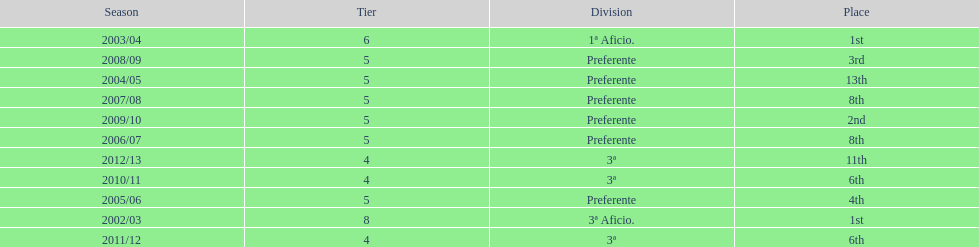How many times did internacional de madrid cf end the season at the top of their division? 2. 